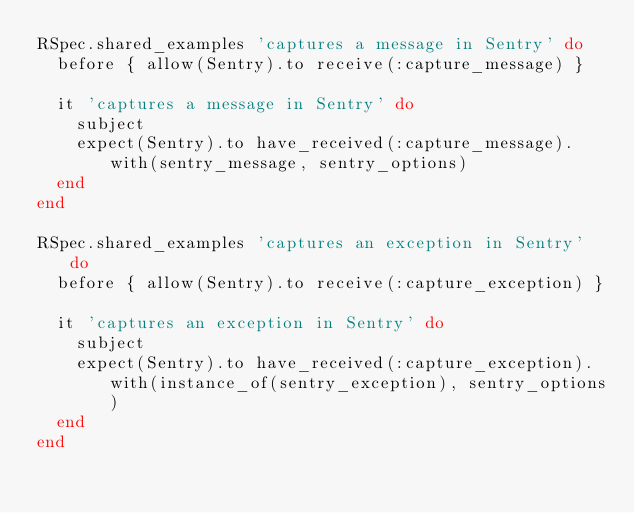<code> <loc_0><loc_0><loc_500><loc_500><_Ruby_>RSpec.shared_examples 'captures a message in Sentry' do
  before { allow(Sentry).to receive(:capture_message) }

  it 'captures a message in Sentry' do
    subject
    expect(Sentry).to have_received(:capture_message).with(sentry_message, sentry_options)
  end
end

RSpec.shared_examples 'captures an exception in Sentry' do
  before { allow(Sentry).to receive(:capture_exception) }

  it 'captures an exception in Sentry' do
    subject
    expect(Sentry).to have_received(:capture_exception).with(instance_of(sentry_exception), sentry_options)
  end
end
</code> 